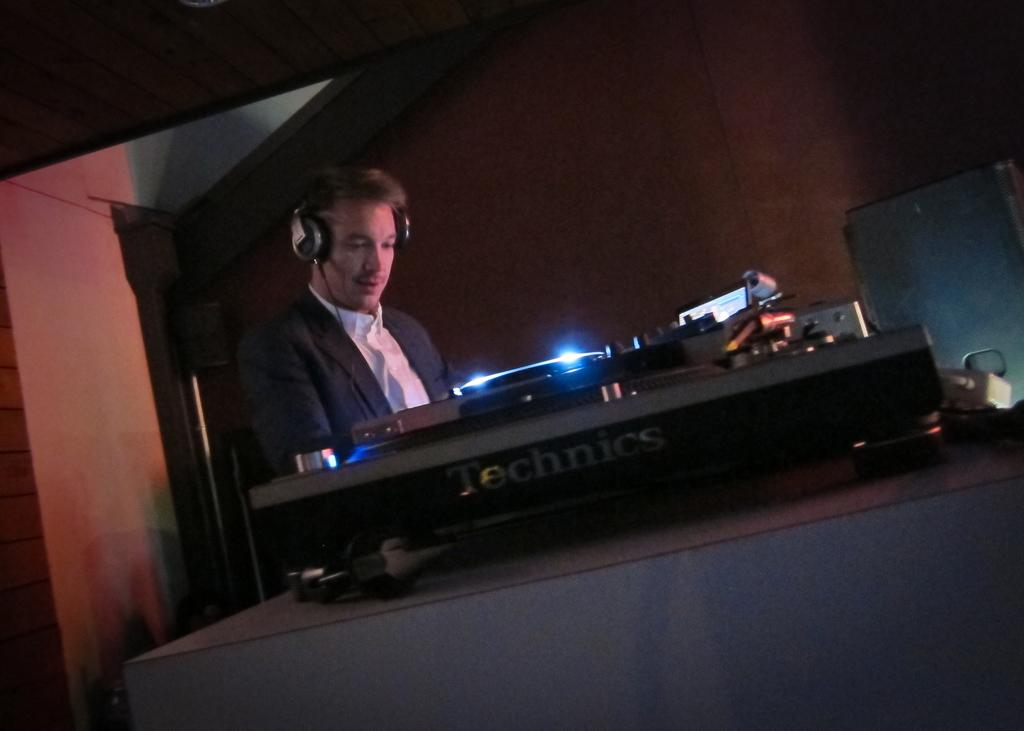<image>
Summarize the visual content of the image. A man plays a record on a Technics turntable. 